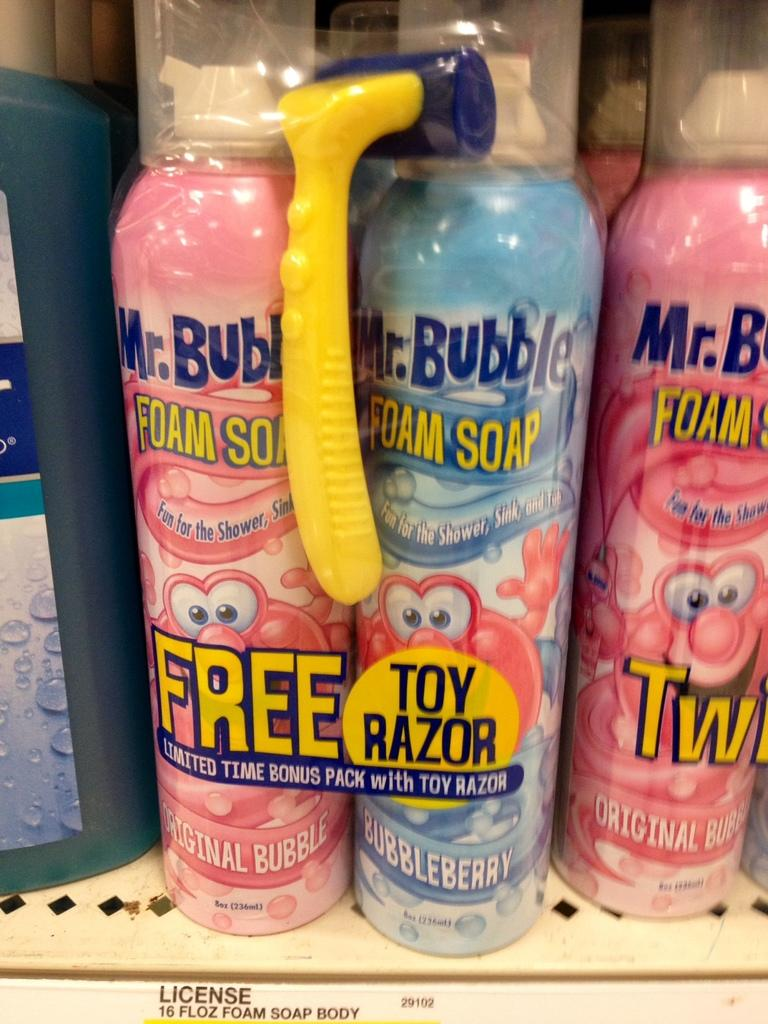<image>
Write a terse but informative summary of the picture. A store display for pink and blue Mr. Bubble Foam Soap 